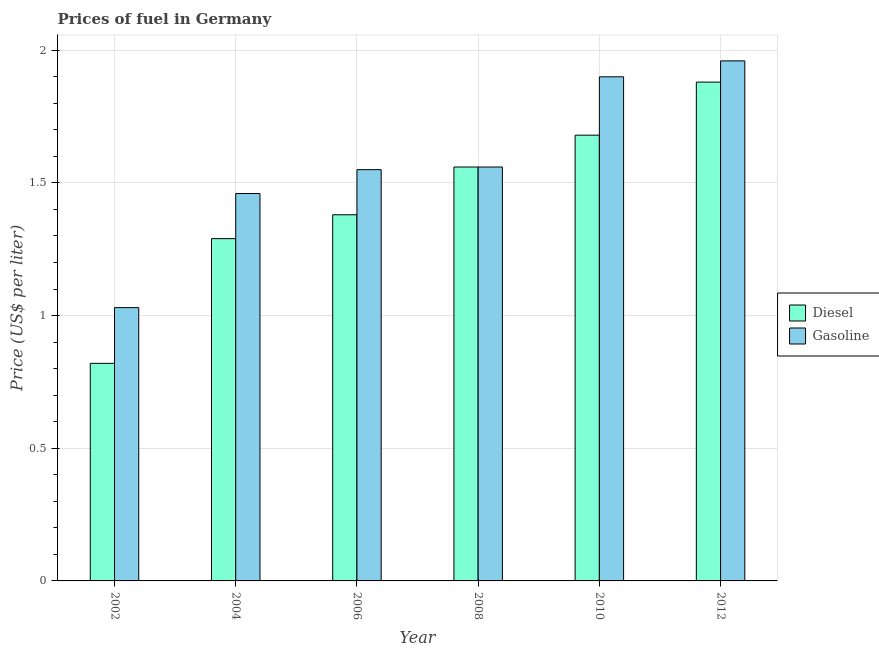How many groups of bars are there?
Ensure brevity in your answer.  6. How many bars are there on the 5th tick from the left?
Offer a very short reply. 2. How many bars are there on the 4th tick from the right?
Your response must be concise. 2. What is the diesel price in 2002?
Provide a succinct answer. 0.82. Across all years, what is the maximum gasoline price?
Make the answer very short. 1.96. In which year was the diesel price minimum?
Your response must be concise. 2002. What is the total diesel price in the graph?
Provide a short and direct response. 8.61. What is the difference between the gasoline price in 2006 and that in 2010?
Make the answer very short. -0.35. What is the difference between the diesel price in 2012 and the gasoline price in 2004?
Your answer should be compact. 0.59. What is the average gasoline price per year?
Provide a short and direct response. 1.58. What is the ratio of the diesel price in 2002 to that in 2012?
Keep it short and to the point. 0.44. Is the difference between the diesel price in 2006 and 2010 greater than the difference between the gasoline price in 2006 and 2010?
Make the answer very short. No. What is the difference between the highest and the second highest diesel price?
Provide a succinct answer. 0.2. What is the difference between the highest and the lowest gasoline price?
Make the answer very short. 0.93. What does the 1st bar from the left in 2004 represents?
Offer a very short reply. Diesel. What does the 1st bar from the right in 2008 represents?
Offer a very short reply. Gasoline. Are all the bars in the graph horizontal?
Provide a succinct answer. No. Are the values on the major ticks of Y-axis written in scientific E-notation?
Keep it short and to the point. No. Where does the legend appear in the graph?
Provide a short and direct response. Center right. How many legend labels are there?
Ensure brevity in your answer.  2. What is the title of the graph?
Ensure brevity in your answer.  Prices of fuel in Germany. Does "Private consumption" appear as one of the legend labels in the graph?
Your response must be concise. No. What is the label or title of the X-axis?
Provide a succinct answer. Year. What is the label or title of the Y-axis?
Your answer should be compact. Price (US$ per liter). What is the Price (US$ per liter) in Diesel in 2002?
Your response must be concise. 0.82. What is the Price (US$ per liter) of Diesel in 2004?
Offer a very short reply. 1.29. What is the Price (US$ per liter) in Gasoline in 2004?
Keep it short and to the point. 1.46. What is the Price (US$ per liter) in Diesel in 2006?
Your answer should be compact. 1.38. What is the Price (US$ per liter) of Gasoline in 2006?
Make the answer very short. 1.55. What is the Price (US$ per liter) of Diesel in 2008?
Give a very brief answer. 1.56. What is the Price (US$ per liter) in Gasoline in 2008?
Offer a terse response. 1.56. What is the Price (US$ per liter) of Diesel in 2010?
Give a very brief answer. 1.68. What is the Price (US$ per liter) of Diesel in 2012?
Make the answer very short. 1.88. What is the Price (US$ per liter) in Gasoline in 2012?
Provide a succinct answer. 1.96. Across all years, what is the maximum Price (US$ per liter) of Diesel?
Ensure brevity in your answer.  1.88. Across all years, what is the maximum Price (US$ per liter) of Gasoline?
Offer a very short reply. 1.96. Across all years, what is the minimum Price (US$ per liter) in Diesel?
Give a very brief answer. 0.82. Across all years, what is the minimum Price (US$ per liter) in Gasoline?
Provide a short and direct response. 1.03. What is the total Price (US$ per liter) in Diesel in the graph?
Your response must be concise. 8.61. What is the total Price (US$ per liter) of Gasoline in the graph?
Offer a terse response. 9.46. What is the difference between the Price (US$ per liter) in Diesel in 2002 and that in 2004?
Offer a terse response. -0.47. What is the difference between the Price (US$ per liter) in Gasoline in 2002 and that in 2004?
Your answer should be compact. -0.43. What is the difference between the Price (US$ per liter) of Diesel in 2002 and that in 2006?
Offer a terse response. -0.56. What is the difference between the Price (US$ per liter) of Gasoline in 2002 and that in 2006?
Offer a very short reply. -0.52. What is the difference between the Price (US$ per liter) in Diesel in 2002 and that in 2008?
Offer a terse response. -0.74. What is the difference between the Price (US$ per liter) of Gasoline in 2002 and that in 2008?
Make the answer very short. -0.53. What is the difference between the Price (US$ per liter) in Diesel in 2002 and that in 2010?
Your response must be concise. -0.86. What is the difference between the Price (US$ per liter) of Gasoline in 2002 and that in 2010?
Give a very brief answer. -0.87. What is the difference between the Price (US$ per liter) in Diesel in 2002 and that in 2012?
Provide a short and direct response. -1.06. What is the difference between the Price (US$ per liter) of Gasoline in 2002 and that in 2012?
Your answer should be very brief. -0.93. What is the difference between the Price (US$ per liter) in Diesel in 2004 and that in 2006?
Provide a succinct answer. -0.09. What is the difference between the Price (US$ per liter) in Gasoline in 2004 and that in 2006?
Your answer should be compact. -0.09. What is the difference between the Price (US$ per liter) of Diesel in 2004 and that in 2008?
Ensure brevity in your answer.  -0.27. What is the difference between the Price (US$ per liter) of Gasoline in 2004 and that in 2008?
Provide a short and direct response. -0.1. What is the difference between the Price (US$ per liter) of Diesel in 2004 and that in 2010?
Ensure brevity in your answer.  -0.39. What is the difference between the Price (US$ per liter) in Gasoline in 2004 and that in 2010?
Offer a very short reply. -0.44. What is the difference between the Price (US$ per liter) of Diesel in 2004 and that in 2012?
Your answer should be compact. -0.59. What is the difference between the Price (US$ per liter) of Gasoline in 2004 and that in 2012?
Offer a terse response. -0.5. What is the difference between the Price (US$ per liter) of Diesel in 2006 and that in 2008?
Your answer should be compact. -0.18. What is the difference between the Price (US$ per liter) of Gasoline in 2006 and that in 2008?
Offer a terse response. -0.01. What is the difference between the Price (US$ per liter) in Gasoline in 2006 and that in 2010?
Offer a very short reply. -0.35. What is the difference between the Price (US$ per liter) in Gasoline in 2006 and that in 2012?
Your response must be concise. -0.41. What is the difference between the Price (US$ per liter) in Diesel in 2008 and that in 2010?
Keep it short and to the point. -0.12. What is the difference between the Price (US$ per liter) of Gasoline in 2008 and that in 2010?
Provide a short and direct response. -0.34. What is the difference between the Price (US$ per liter) in Diesel in 2008 and that in 2012?
Offer a very short reply. -0.32. What is the difference between the Price (US$ per liter) in Diesel in 2010 and that in 2012?
Ensure brevity in your answer.  -0.2. What is the difference between the Price (US$ per liter) of Gasoline in 2010 and that in 2012?
Provide a short and direct response. -0.06. What is the difference between the Price (US$ per liter) of Diesel in 2002 and the Price (US$ per liter) of Gasoline in 2004?
Give a very brief answer. -0.64. What is the difference between the Price (US$ per liter) of Diesel in 2002 and the Price (US$ per liter) of Gasoline in 2006?
Make the answer very short. -0.73. What is the difference between the Price (US$ per liter) of Diesel in 2002 and the Price (US$ per liter) of Gasoline in 2008?
Make the answer very short. -0.74. What is the difference between the Price (US$ per liter) of Diesel in 2002 and the Price (US$ per liter) of Gasoline in 2010?
Offer a terse response. -1.08. What is the difference between the Price (US$ per liter) of Diesel in 2002 and the Price (US$ per liter) of Gasoline in 2012?
Make the answer very short. -1.14. What is the difference between the Price (US$ per liter) in Diesel in 2004 and the Price (US$ per liter) in Gasoline in 2006?
Offer a very short reply. -0.26. What is the difference between the Price (US$ per liter) in Diesel in 2004 and the Price (US$ per liter) in Gasoline in 2008?
Give a very brief answer. -0.27. What is the difference between the Price (US$ per liter) of Diesel in 2004 and the Price (US$ per liter) of Gasoline in 2010?
Provide a short and direct response. -0.61. What is the difference between the Price (US$ per liter) of Diesel in 2004 and the Price (US$ per liter) of Gasoline in 2012?
Your answer should be very brief. -0.67. What is the difference between the Price (US$ per liter) in Diesel in 2006 and the Price (US$ per liter) in Gasoline in 2008?
Ensure brevity in your answer.  -0.18. What is the difference between the Price (US$ per liter) of Diesel in 2006 and the Price (US$ per liter) of Gasoline in 2010?
Offer a very short reply. -0.52. What is the difference between the Price (US$ per liter) of Diesel in 2006 and the Price (US$ per liter) of Gasoline in 2012?
Keep it short and to the point. -0.58. What is the difference between the Price (US$ per liter) in Diesel in 2008 and the Price (US$ per liter) in Gasoline in 2010?
Give a very brief answer. -0.34. What is the difference between the Price (US$ per liter) of Diesel in 2008 and the Price (US$ per liter) of Gasoline in 2012?
Give a very brief answer. -0.4. What is the difference between the Price (US$ per liter) in Diesel in 2010 and the Price (US$ per liter) in Gasoline in 2012?
Give a very brief answer. -0.28. What is the average Price (US$ per liter) in Diesel per year?
Provide a short and direct response. 1.44. What is the average Price (US$ per liter) in Gasoline per year?
Give a very brief answer. 1.58. In the year 2002, what is the difference between the Price (US$ per liter) of Diesel and Price (US$ per liter) of Gasoline?
Provide a short and direct response. -0.21. In the year 2004, what is the difference between the Price (US$ per liter) in Diesel and Price (US$ per liter) in Gasoline?
Provide a short and direct response. -0.17. In the year 2006, what is the difference between the Price (US$ per liter) of Diesel and Price (US$ per liter) of Gasoline?
Give a very brief answer. -0.17. In the year 2010, what is the difference between the Price (US$ per liter) of Diesel and Price (US$ per liter) of Gasoline?
Make the answer very short. -0.22. In the year 2012, what is the difference between the Price (US$ per liter) of Diesel and Price (US$ per liter) of Gasoline?
Offer a very short reply. -0.08. What is the ratio of the Price (US$ per liter) in Diesel in 2002 to that in 2004?
Give a very brief answer. 0.64. What is the ratio of the Price (US$ per liter) in Gasoline in 2002 to that in 2004?
Offer a very short reply. 0.71. What is the ratio of the Price (US$ per liter) in Diesel in 2002 to that in 2006?
Your answer should be very brief. 0.59. What is the ratio of the Price (US$ per liter) of Gasoline in 2002 to that in 2006?
Give a very brief answer. 0.66. What is the ratio of the Price (US$ per liter) of Diesel in 2002 to that in 2008?
Your answer should be very brief. 0.53. What is the ratio of the Price (US$ per liter) in Gasoline in 2002 to that in 2008?
Offer a very short reply. 0.66. What is the ratio of the Price (US$ per liter) of Diesel in 2002 to that in 2010?
Your response must be concise. 0.49. What is the ratio of the Price (US$ per liter) of Gasoline in 2002 to that in 2010?
Offer a very short reply. 0.54. What is the ratio of the Price (US$ per liter) of Diesel in 2002 to that in 2012?
Offer a terse response. 0.44. What is the ratio of the Price (US$ per liter) in Gasoline in 2002 to that in 2012?
Provide a short and direct response. 0.53. What is the ratio of the Price (US$ per liter) of Diesel in 2004 to that in 2006?
Offer a very short reply. 0.93. What is the ratio of the Price (US$ per liter) of Gasoline in 2004 to that in 2006?
Offer a very short reply. 0.94. What is the ratio of the Price (US$ per liter) of Diesel in 2004 to that in 2008?
Keep it short and to the point. 0.83. What is the ratio of the Price (US$ per liter) in Gasoline in 2004 to that in 2008?
Ensure brevity in your answer.  0.94. What is the ratio of the Price (US$ per liter) in Diesel in 2004 to that in 2010?
Make the answer very short. 0.77. What is the ratio of the Price (US$ per liter) in Gasoline in 2004 to that in 2010?
Provide a succinct answer. 0.77. What is the ratio of the Price (US$ per liter) of Diesel in 2004 to that in 2012?
Keep it short and to the point. 0.69. What is the ratio of the Price (US$ per liter) of Gasoline in 2004 to that in 2012?
Ensure brevity in your answer.  0.74. What is the ratio of the Price (US$ per liter) in Diesel in 2006 to that in 2008?
Provide a succinct answer. 0.88. What is the ratio of the Price (US$ per liter) in Diesel in 2006 to that in 2010?
Make the answer very short. 0.82. What is the ratio of the Price (US$ per liter) in Gasoline in 2006 to that in 2010?
Your answer should be compact. 0.82. What is the ratio of the Price (US$ per liter) in Diesel in 2006 to that in 2012?
Keep it short and to the point. 0.73. What is the ratio of the Price (US$ per liter) in Gasoline in 2006 to that in 2012?
Offer a very short reply. 0.79. What is the ratio of the Price (US$ per liter) of Gasoline in 2008 to that in 2010?
Your answer should be compact. 0.82. What is the ratio of the Price (US$ per liter) in Diesel in 2008 to that in 2012?
Your response must be concise. 0.83. What is the ratio of the Price (US$ per liter) of Gasoline in 2008 to that in 2012?
Your response must be concise. 0.8. What is the ratio of the Price (US$ per liter) in Diesel in 2010 to that in 2012?
Keep it short and to the point. 0.89. What is the ratio of the Price (US$ per liter) of Gasoline in 2010 to that in 2012?
Offer a terse response. 0.97. What is the difference between the highest and the second highest Price (US$ per liter) in Gasoline?
Your answer should be compact. 0.06. What is the difference between the highest and the lowest Price (US$ per liter) of Diesel?
Provide a short and direct response. 1.06. What is the difference between the highest and the lowest Price (US$ per liter) in Gasoline?
Ensure brevity in your answer.  0.93. 